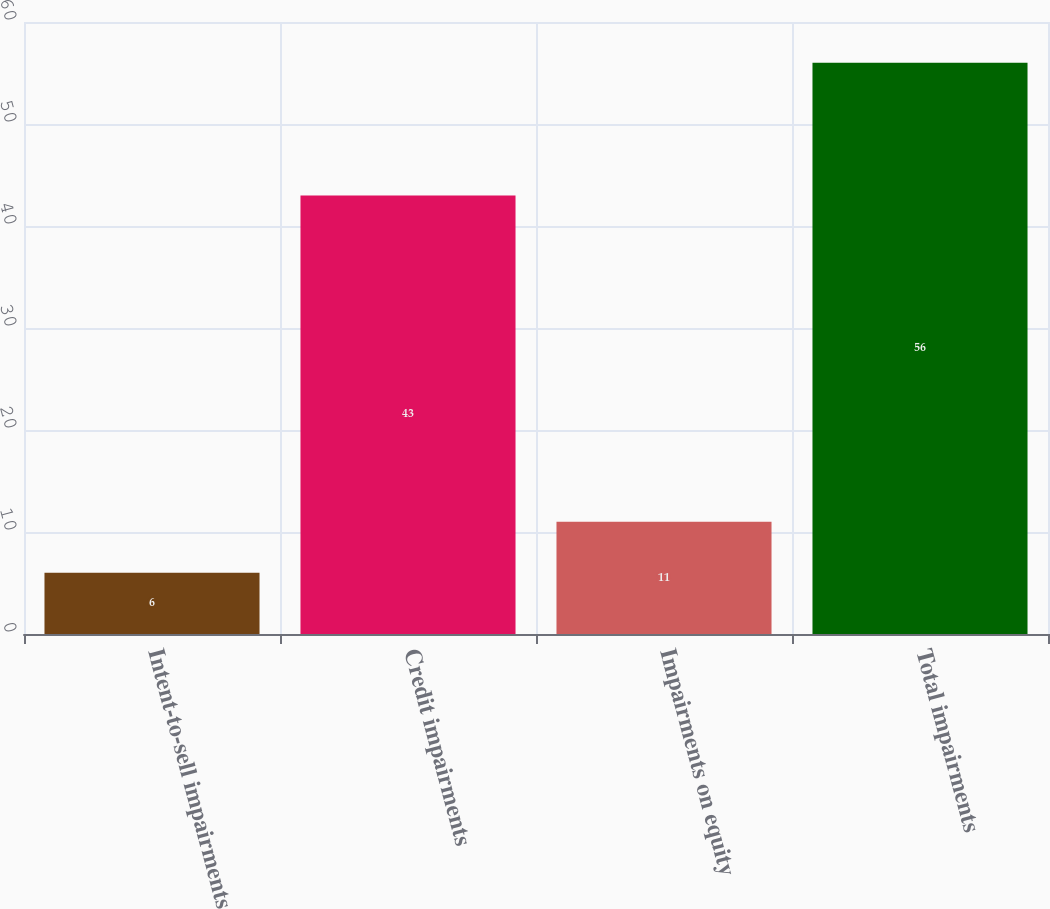Convert chart. <chart><loc_0><loc_0><loc_500><loc_500><bar_chart><fcel>Intent-to-sell impairments<fcel>Credit impairments<fcel>Impairments on equity<fcel>Total impairments<nl><fcel>6<fcel>43<fcel>11<fcel>56<nl></chart> 